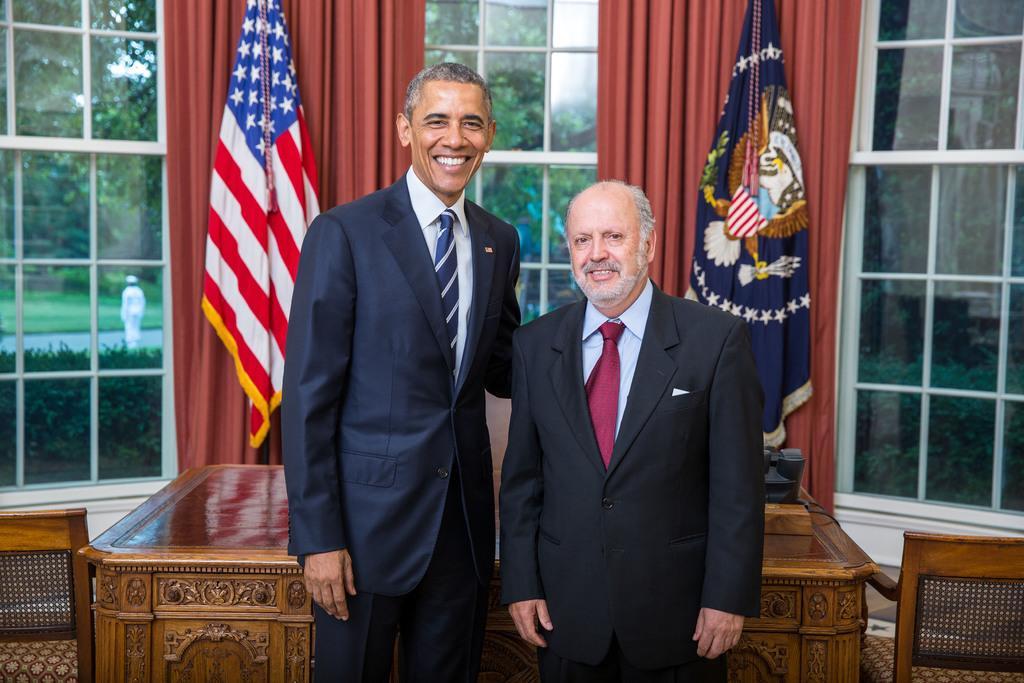Describe this image in one or two sentences. Here we can see two people are standing and smiling. Background there are chairs, table, flags, curtains and glass windows. Through these glass windows we can see a person, plants, grass and trees. 